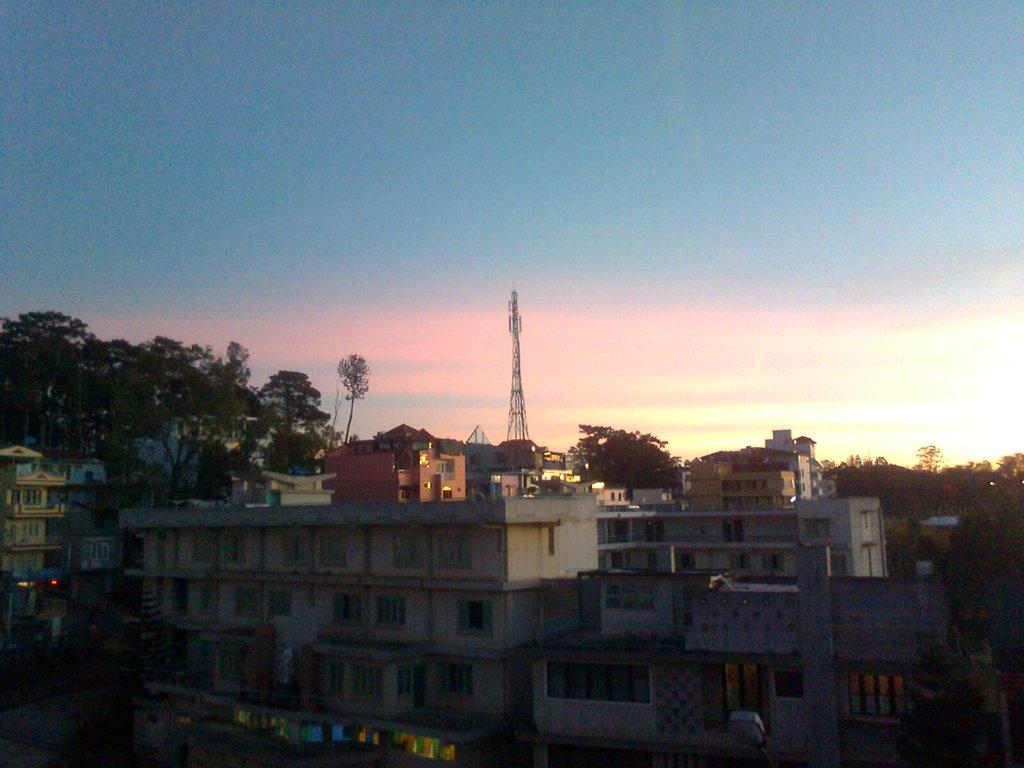What type of structures can be seen in the image? There are buildings and a tower in the image. What other natural elements are present in the image? There are trees in the image. What can be seen in the background of the image? The sky is visible in the background of the image. What type of drum is being played in the image? There is no drum present in the image. What scientific experiment is being conducted in the image? There is no scientific experiment depicted in the image. 